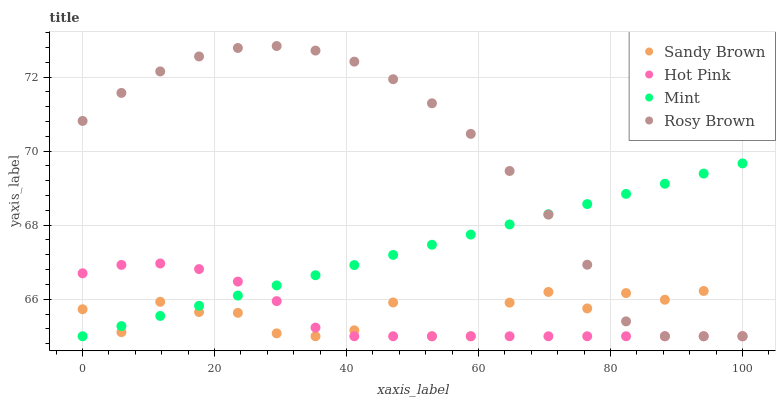Does Hot Pink have the minimum area under the curve?
Answer yes or no. Yes. Does Rosy Brown have the maximum area under the curve?
Answer yes or no. Yes. Does Rosy Brown have the minimum area under the curve?
Answer yes or no. No. Does Hot Pink have the maximum area under the curve?
Answer yes or no. No. Is Mint the smoothest?
Answer yes or no. Yes. Is Sandy Brown the roughest?
Answer yes or no. Yes. Is Rosy Brown the smoothest?
Answer yes or no. No. Is Rosy Brown the roughest?
Answer yes or no. No. Does Mint have the lowest value?
Answer yes or no. Yes. Does Rosy Brown have the highest value?
Answer yes or no. Yes. Does Hot Pink have the highest value?
Answer yes or no. No. Does Mint intersect Hot Pink?
Answer yes or no. Yes. Is Mint less than Hot Pink?
Answer yes or no. No. Is Mint greater than Hot Pink?
Answer yes or no. No. 